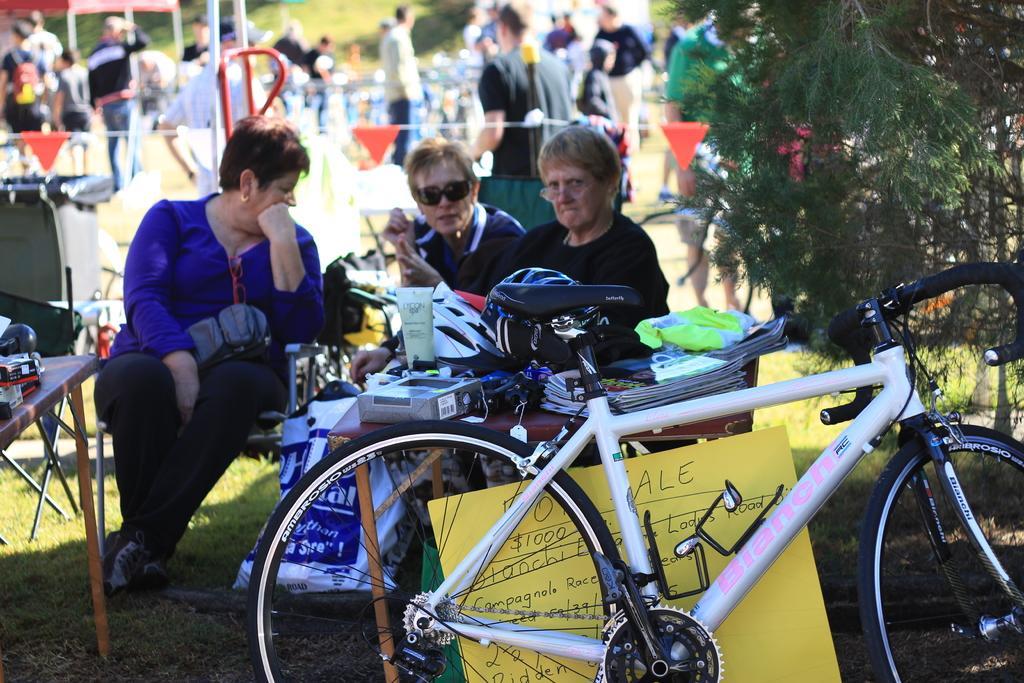In one or two sentences, can you explain what this image depicts? As we can see in the image there are lot of people gathered and here we can see there are three women sitting on the chair beside them there is a tree and in front of them there is a table on which there are books, cover, helmet, body lotion tube and box. In Front of the table there is a white cycle and on the ground there are a lot of grass. 